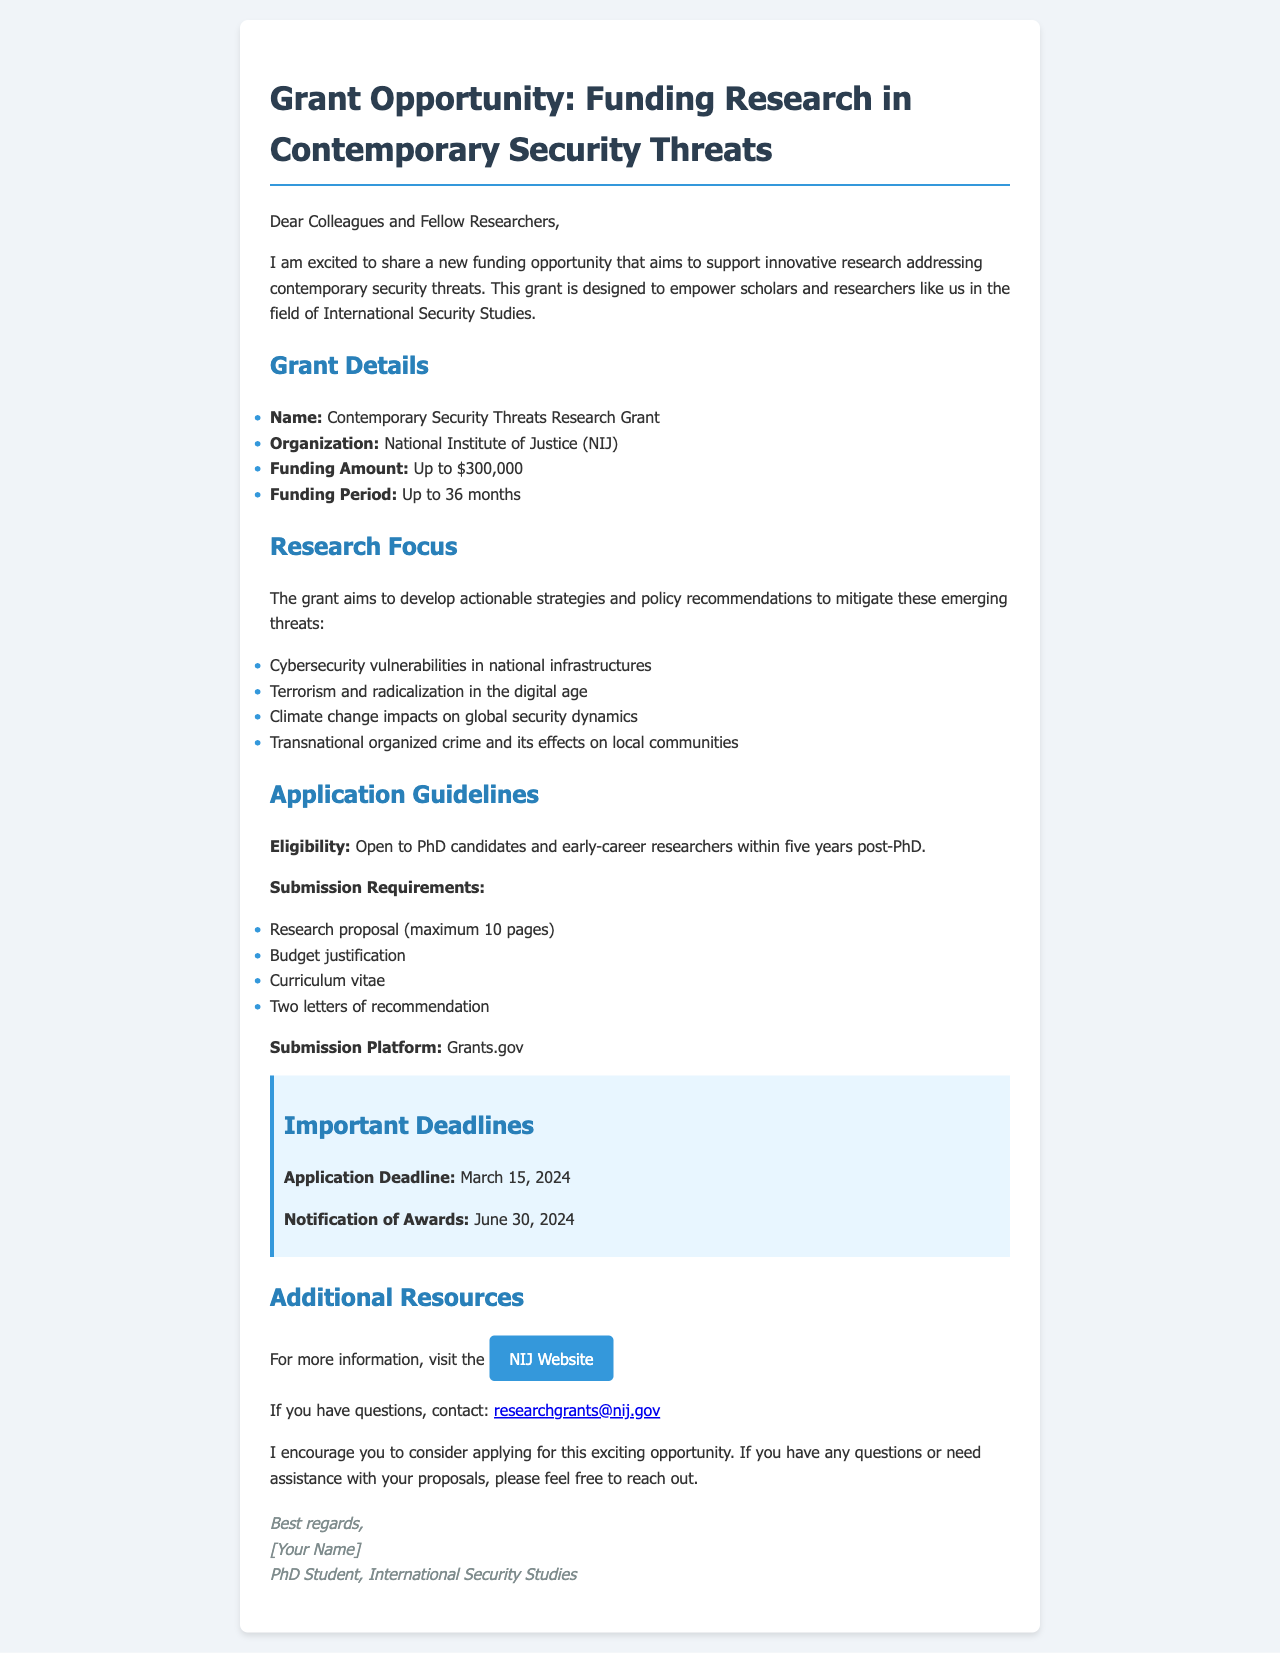What is the name of the grant? The name of the grant is clearly stated in the document under the Grant Details section.
Answer: Contemporary Security Threats Research Grant Who is the funding organization? The document specifies the organization providing the funding in the Grant Details section.
Answer: National Institute of Justice (NIJ) What is the maximum funding amount available? The maximum funding amount is provided in the Grant Details section of the document.
Answer: Up to $300,000 What is the application deadline? The application deadline is highlighted in the Important Deadlines section of the document.
Answer: March 15, 2024 How long can the funding period last? The document indicates the duration of the funding period in the Grant Details section.
Answer: Up to 36 months What types of researchers are eligible to apply? The eligibility criteria are outlined in the Application Guidelines section of the document.
Answer: PhD candidates and early-career researchers within five years post-PhD What are two submission requirements for the application? Key submission requirements are listed in the Application Guidelines section.
Answer: Research proposal, Budget justification What is the notification date for awards? This date is specified in the Important Deadlines section.
Answer: June 30, 2024 Where can more information about the grant be found? The document provides a link for more information in the Additional Resources section.
Answer: NIJ Website 